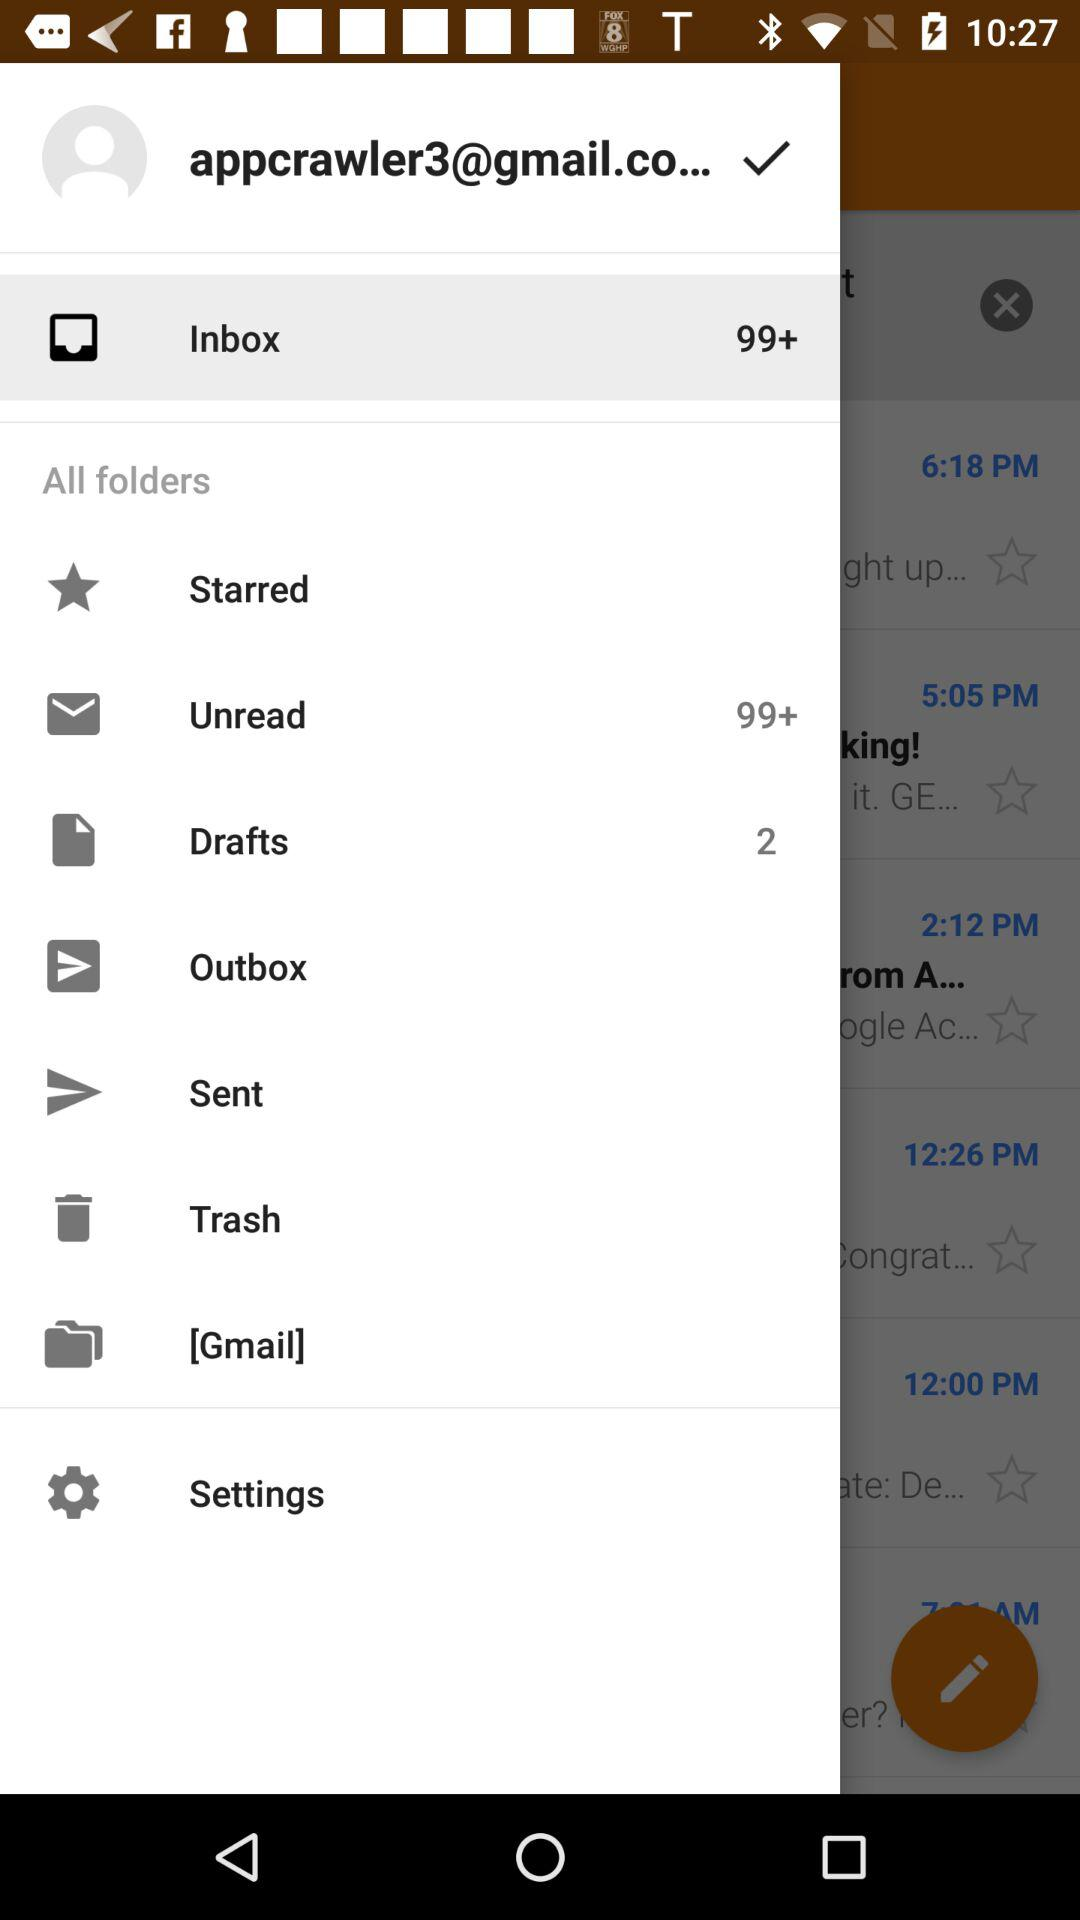How many total unread mails are there in the inbox? There are more than 99 unread mails. 